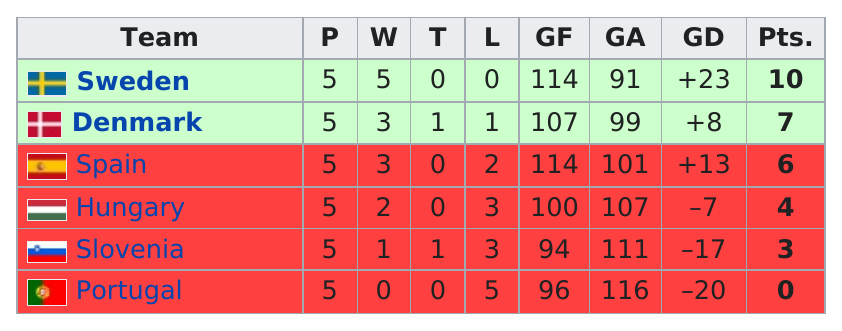List a handful of essential elements in this visual. Portugal had the worst win/tie/loss record among all teams, making it the most unsuccessful team. It is clear that Sweden emerged as the winner in every game. Sweden had the best game differential, making them the top team. In the preliminary round of the 1994 European Men's Handball Championship, Portugal scored 0 points. Sweden won the preliminary round of the 1994 European Men's Handball Championship. 